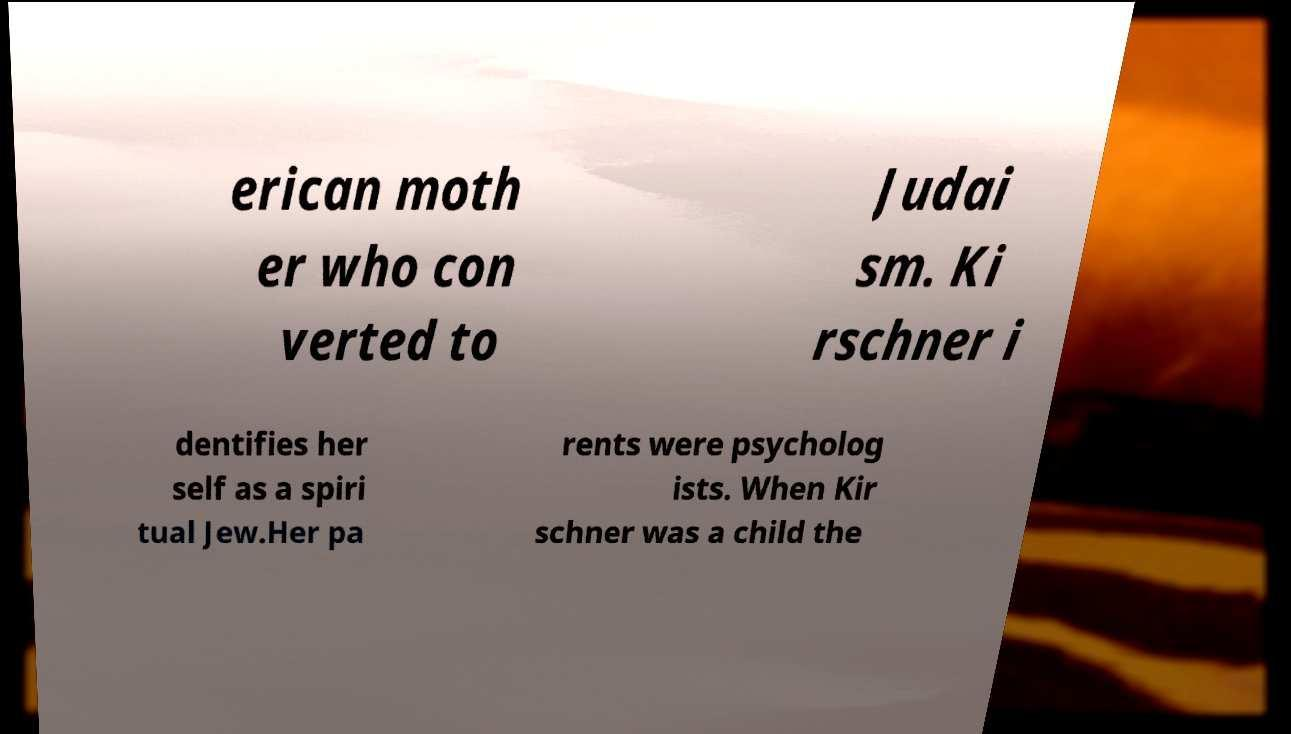Can you read and provide the text displayed in the image?This photo seems to have some interesting text. Can you extract and type it out for me? erican moth er who con verted to Judai sm. Ki rschner i dentifies her self as a spiri tual Jew.Her pa rents were psycholog ists. When Kir schner was a child the 